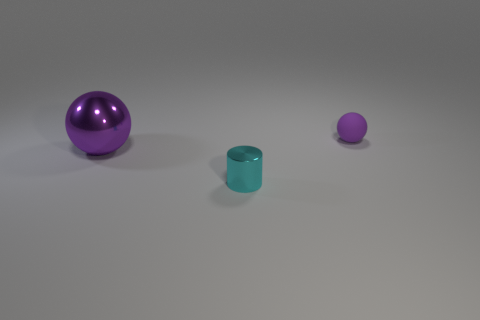Subtract 1 balls. How many balls are left? 1 Add 3 small shiny things. How many objects exist? 6 Subtract all cylinders. How many objects are left? 2 Subtract 0 brown cubes. How many objects are left? 3 Subtract all purple cylinders. Subtract all blue cubes. How many cylinders are left? 1 Subtract all purple objects. Subtract all cyan cylinders. How many objects are left? 0 Add 2 small metal objects. How many small metal objects are left? 3 Add 1 red metal balls. How many red metal balls exist? 1 